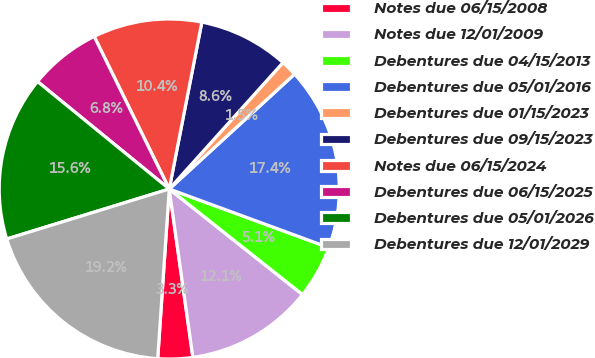Convert chart to OTSL. <chart><loc_0><loc_0><loc_500><loc_500><pie_chart><fcel>Notes due 06/15/2008<fcel>Notes due 12/01/2009<fcel>Debentures due 04/15/2013<fcel>Debentures due 05/01/2016<fcel>Debentures due 01/15/2023<fcel>Debentures due 09/15/2023<fcel>Notes due 06/15/2024<fcel>Debentures due 06/15/2025<fcel>Debentures due 05/01/2026<fcel>Debentures due 12/01/2029<nl><fcel>3.3%<fcel>12.12%<fcel>5.06%<fcel>17.41%<fcel>1.53%<fcel>8.59%<fcel>10.35%<fcel>6.83%<fcel>15.64%<fcel>19.17%<nl></chart> 